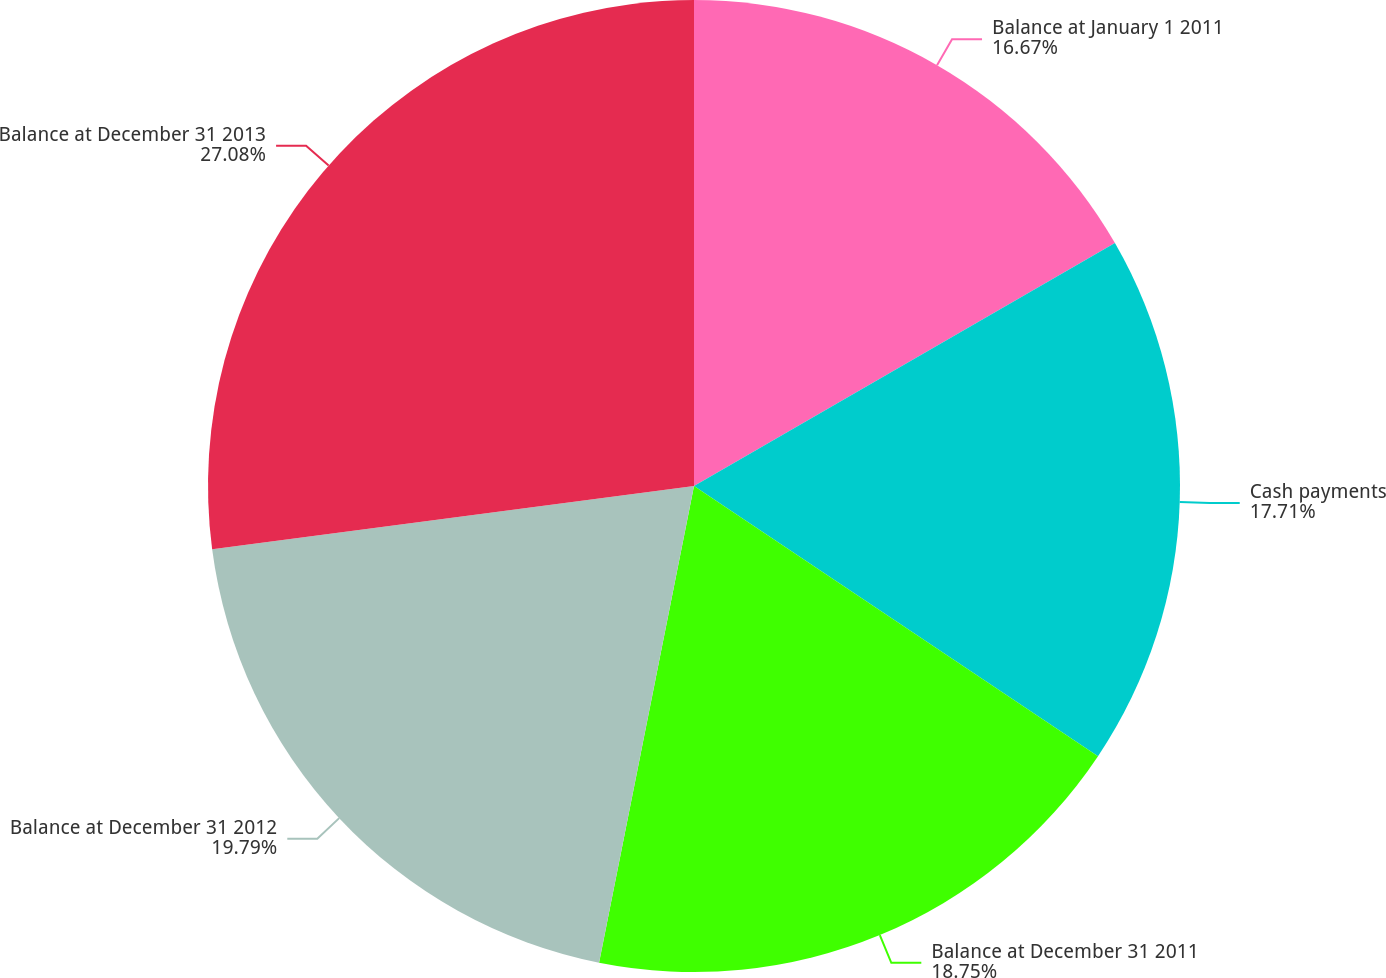Convert chart. <chart><loc_0><loc_0><loc_500><loc_500><pie_chart><fcel>Balance at January 1 2011<fcel>Cash payments<fcel>Balance at December 31 2011<fcel>Balance at December 31 2012<fcel>Balance at December 31 2013<nl><fcel>16.67%<fcel>17.71%<fcel>18.75%<fcel>19.79%<fcel>27.08%<nl></chart> 